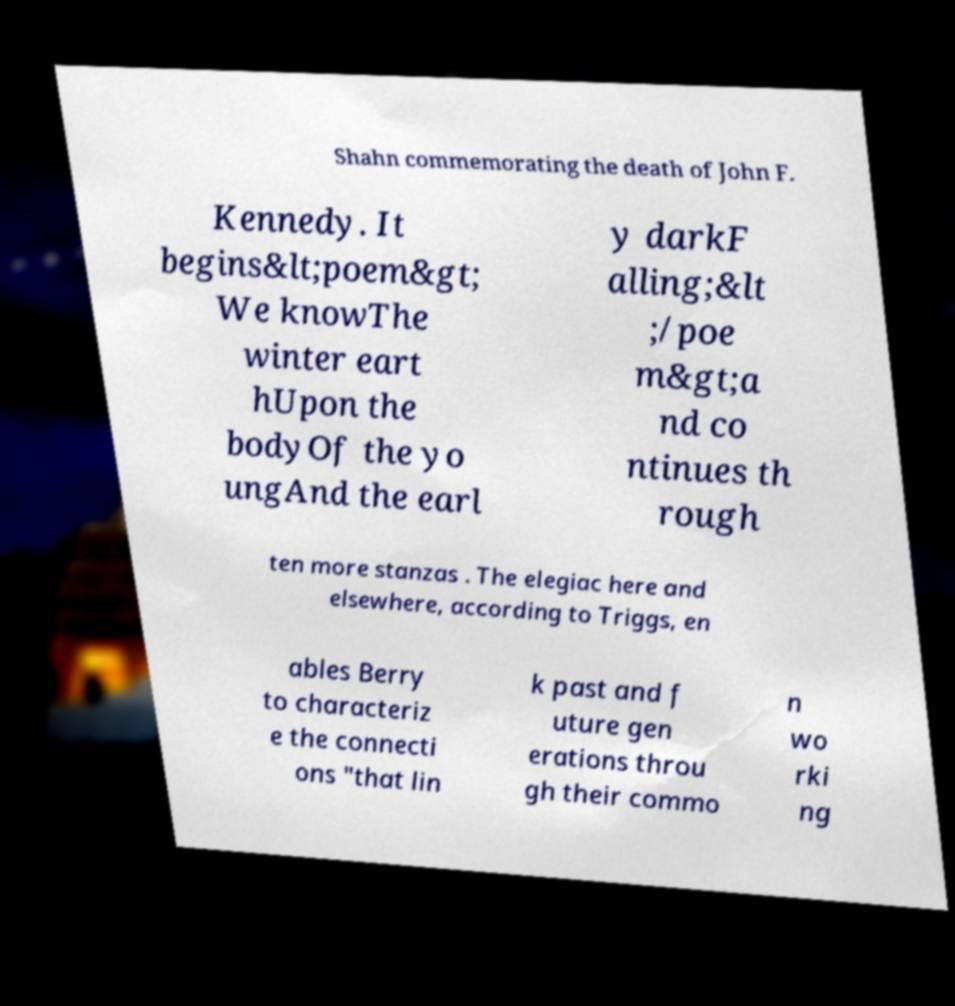Could you assist in decoding the text presented in this image and type it out clearly? Shahn commemorating the death of John F. Kennedy. It begins&lt;poem&gt; We knowThe winter eart hUpon the bodyOf the yo ungAnd the earl y darkF alling;&lt ;/poe m&gt;a nd co ntinues th rough ten more stanzas . The elegiac here and elsewhere, according to Triggs, en ables Berry to characteriz e the connecti ons "that lin k past and f uture gen erations throu gh their commo n wo rki ng 